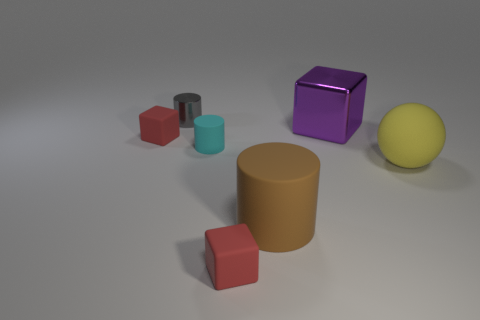Subtract all small blocks. How many blocks are left? 1 Subtract all yellow balls. How many red blocks are left? 2 Add 2 tiny red rubber blocks. How many objects exist? 9 Subtract all balls. How many objects are left? 6 Add 5 yellow spheres. How many yellow spheres exist? 6 Subtract 0 yellow blocks. How many objects are left? 7 Subtract all brown balls. Subtract all purple blocks. How many balls are left? 1 Subtract all cylinders. Subtract all large metallic spheres. How many objects are left? 4 Add 7 big purple blocks. How many big purple blocks are left? 8 